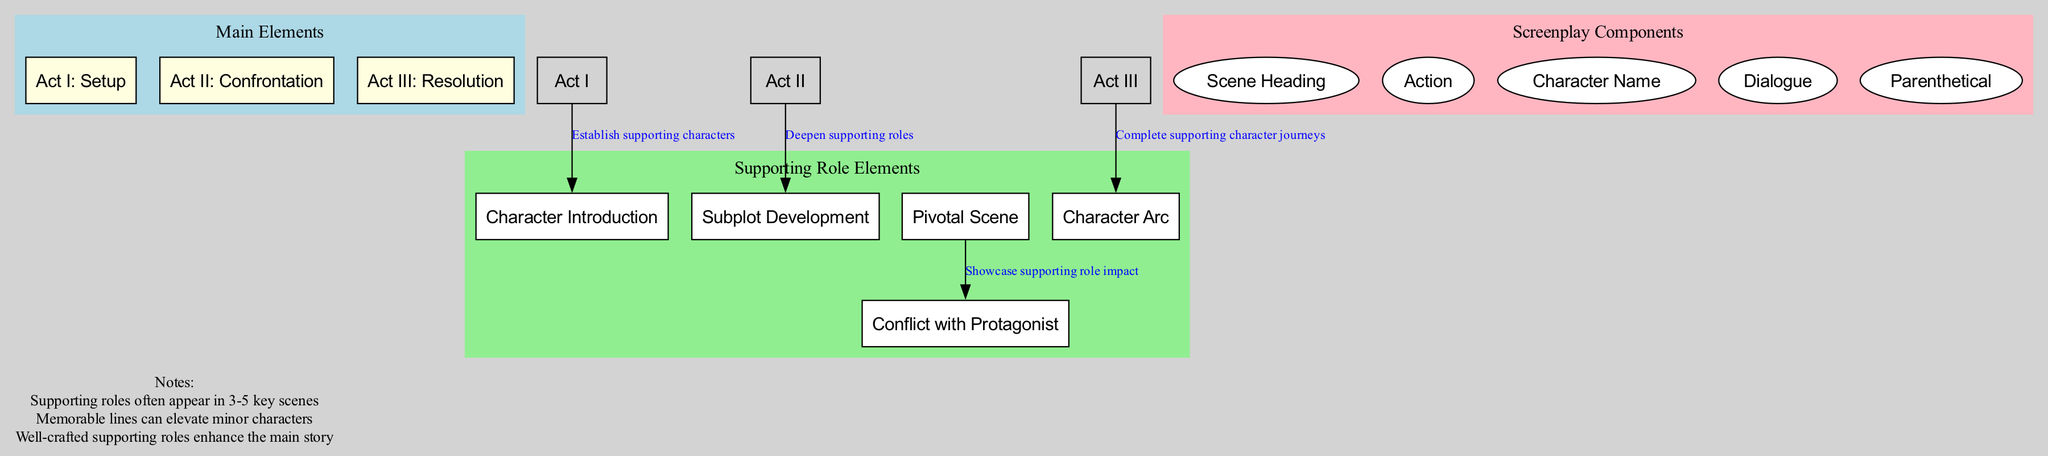What are the main elements of the screenplay structure? The main elements are listed under "Main Elements" in the diagram, which shows Act I, Act II, and Act III.
Answer: Act I: Setup, Act II: Confrontation, Act III: Resolution How many supporting role elements are there? The number of supporting role elements can be counted directly from the "Supporting Role Elements" section, which lists five distinct elements.
Answer: 5 What does "Act I: Setup" connect to? The diagram shows that "Act I: Setup" connects to "Character Introduction," indicating the introduction of supporting characters.
Answer: Character Introduction Which element completes supporting character journeys? The diagram specifies that "Act III: Resolution" connects to "Character Arc," which indicates the completion of supporting character journeys.
Answer: Character Arc What is the relationship between "Pivotal Scene" and "Conflict with Protagonist"? The diagram indicates a connection where "Pivotal Scene" leads to "Conflict with Protagonist," highlighting the showcase of supporting role impact.
Answer: Showcase supporting role impact How many screenplay components are there? The number of screenplay components can be counted from the "Screenplay Components" section, which lists five components.
Answer: 5 What happens in Act II concerning supporting roles? According to the diagram, "Act II: Confrontation" connects to "Subplot Development," which indicates a deepening of supporting roles during this act.
Answer: Deepen supporting roles Which type of scene often showcases the impact of supporting roles? The diagram identifies "Pivotal Scene" as the type of scene that showcases the impact of supporting roles through its connection to "Conflict with Protagonist."
Answer: Pivotal Scene What is stated in the notes about supporting roles? The notes provide insights into supporting roles, highlighting aspects such as their key scenes and impact on the main story, summarizing their importance effectively.
Answer: Supporting roles often appear in 3-5 key scenes 